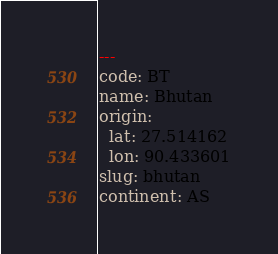Convert code to text. <code><loc_0><loc_0><loc_500><loc_500><_YAML_>---
code: BT
name: Bhutan
origin:
  lat: 27.514162
  lon: 90.433601
slug: bhutan
continent: AS
</code> 